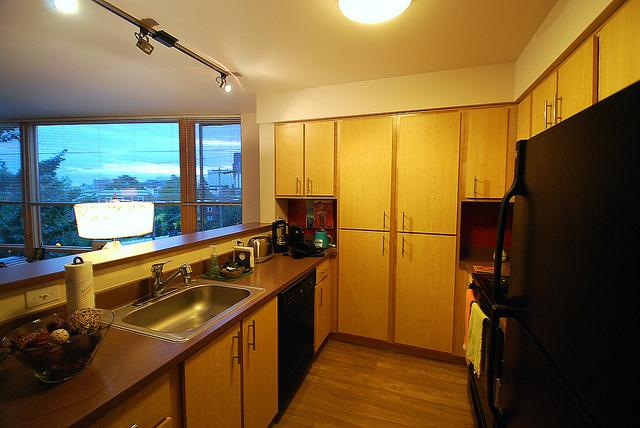What color is the light on top of the sink near the counter? Please explain your reasoning. white. The color is white. 